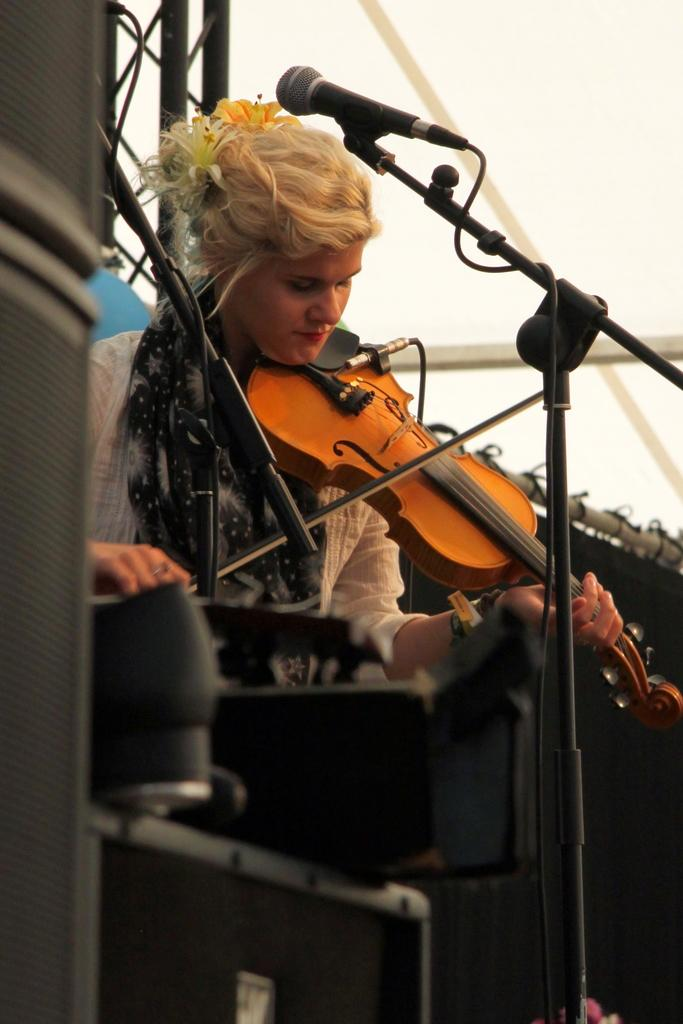Who is the main subject in the image? There is a woman in the image. What is the woman doing in the image? The woman is standing and playing a violin. What type of grain can be seen in the background of the image? There is no grain visible in the image; it features of the woman and her violin are the primary focus. 